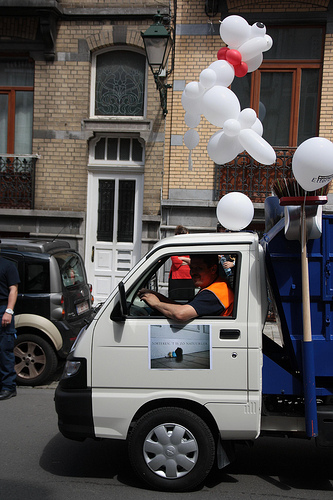<image>
Is the van to the left of the car? Yes. From this viewpoint, the van is positioned to the left side relative to the car. Is there a man in the vehicle? Yes. The man is contained within or inside the vehicle, showing a containment relationship. 